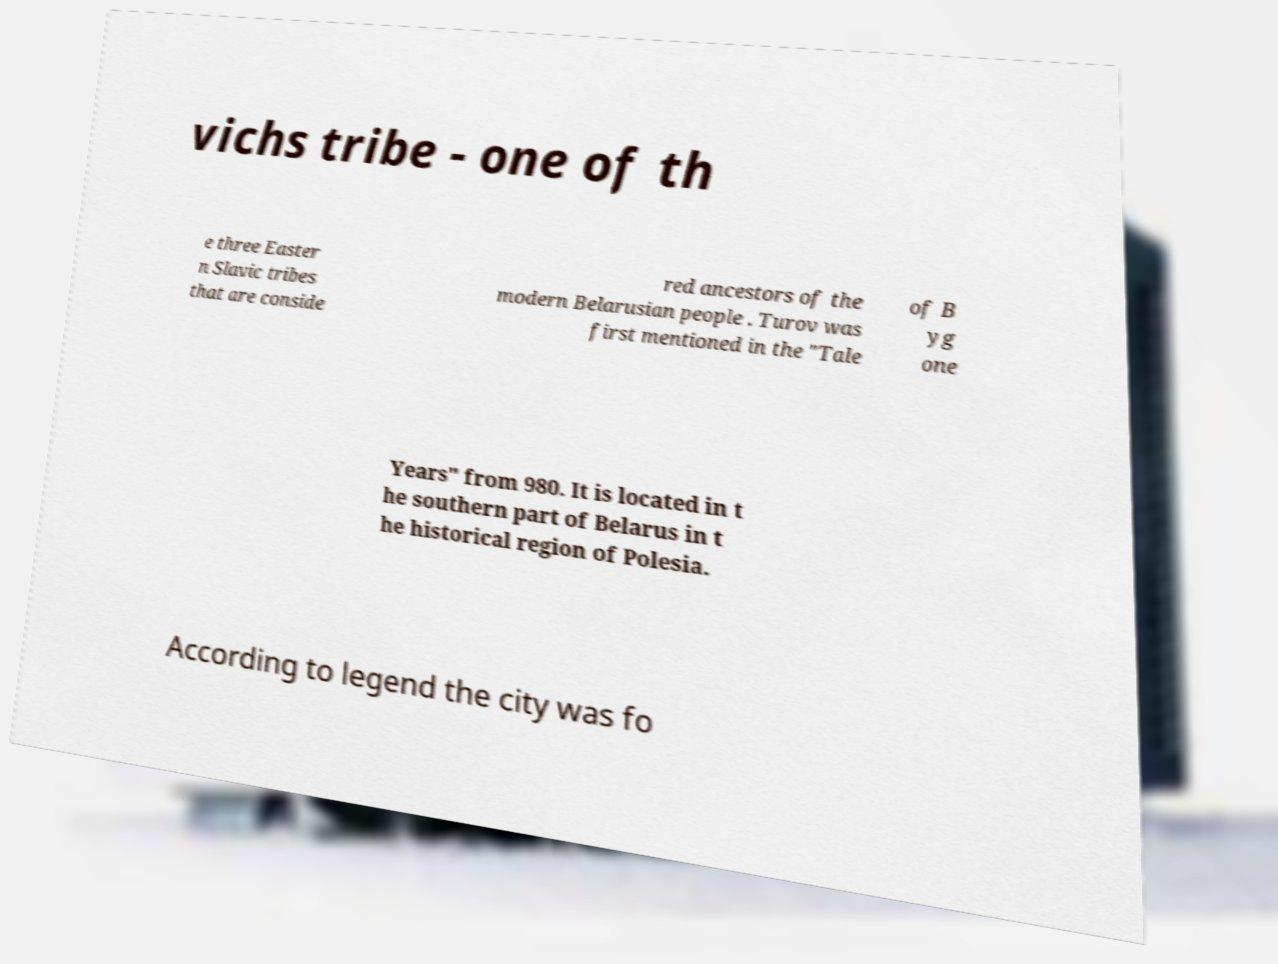Please read and relay the text visible in this image. What does it say? vichs tribe - one of th e three Easter n Slavic tribes that are conside red ancestors of the modern Belarusian people . Turov was first mentioned in the "Tale of B yg one Years" from 980. It is located in t he southern part of Belarus in t he historical region of Polesia. According to legend the city was fo 